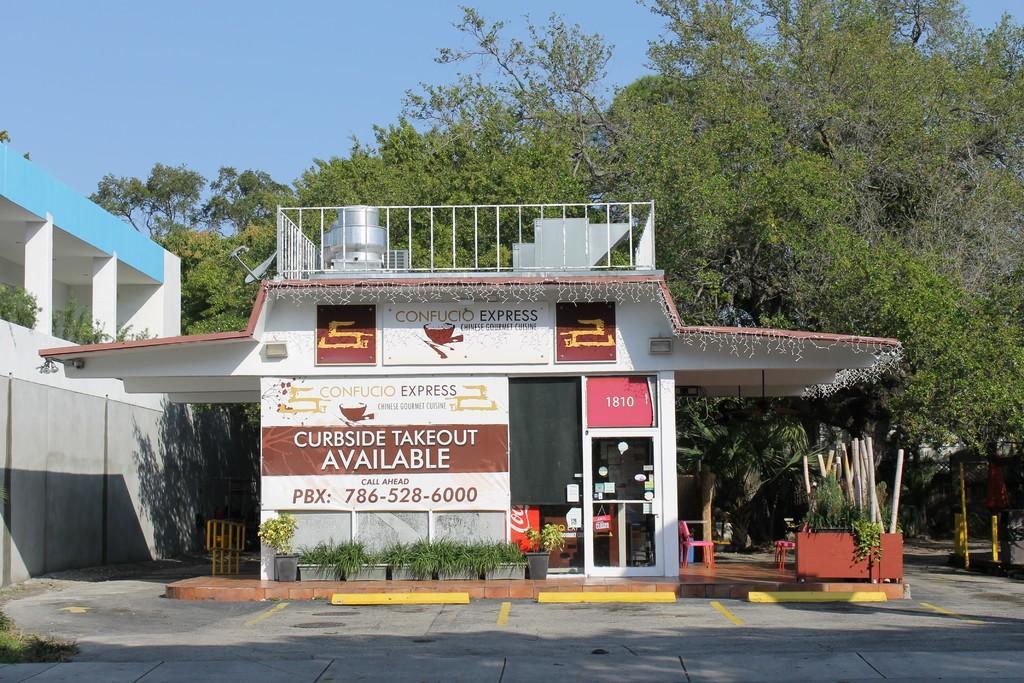Could you give a brief overview of what you see in this image? A store with hoardings. In-front of this store there are plants. Background there are trees. This is building. 